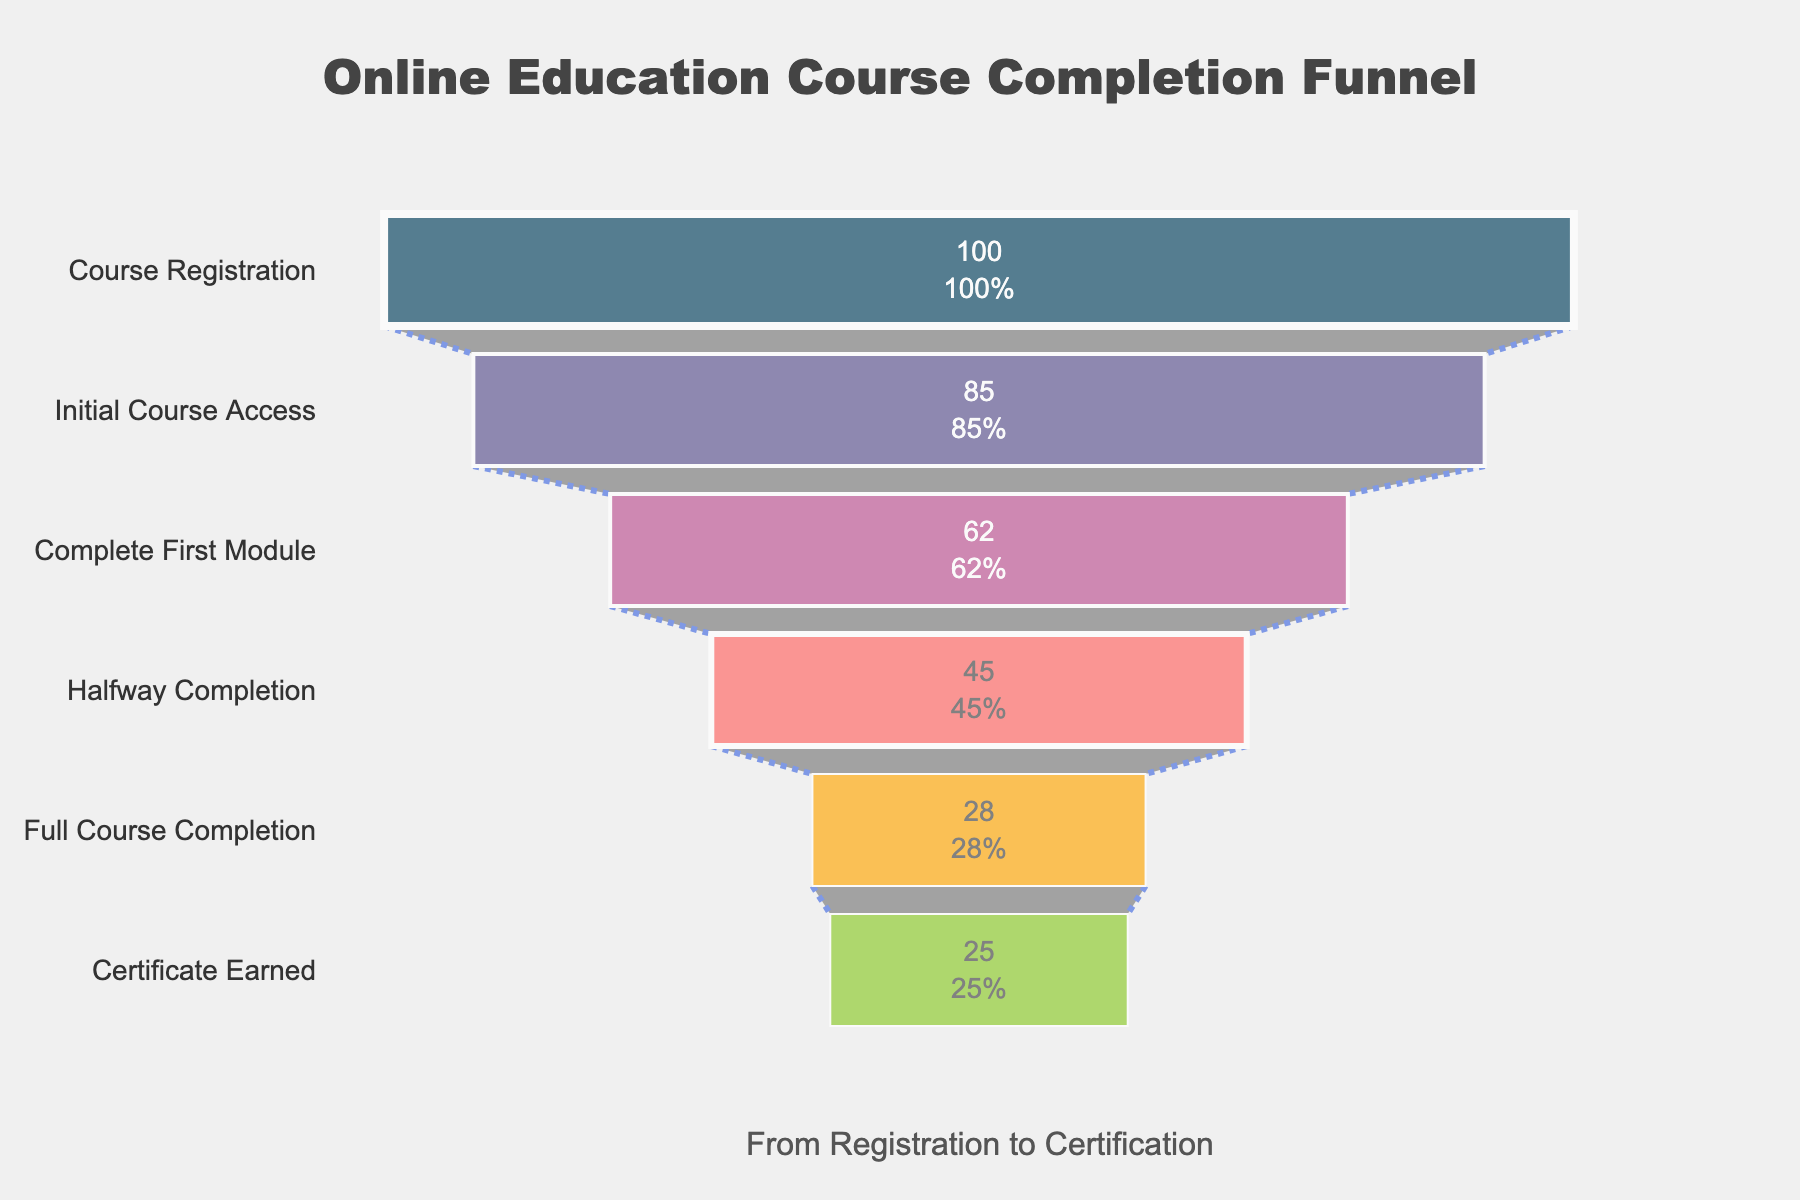What is the title of the funnel chart? The title is located at the top of the chart, and it is prominently displayed in larger font size. It reads "Online Education Course Completion Funnel".
Answer: Online Education Course Completion Funnel Which stage has the largest drop-off in percentage? To find the stage with the largest drop-off, compare the percentage changes between successive stages. The largest drop-off is from the "Initial Course Access" stage (85%) to the "Complete First Module" stage (62%), which is a drop of 23%.
Answer: Initial Course Access to Complete First Module What percentage of users complete the full course? According to the funnel chart, the percentage of users who reach the "Full Course Completion" stage is displayed. It shows 28%.
Answer: 28% What is the difference in percentage between users who register and users who earn a certificate? To find the difference, subtract the percentage of users who earn a certificate (25%) from those who registered (100%). The calculation is 100% - 25% = 75%.
Answer: 75% Which two stages have the smallest percentage difference between them? Compare the percentage differences between all successive stages. The smallest difference is between "Full Course Completion" (28%) and "Certificate Earned" (25%), which is 3%.
Answer: Full Course Completion and Certificate Earned How many unique stages are shown in the chart? Count the number of distinct stages listed on the y-axis. They are six: Course Registration, Initial Course Access, Complete First Module, Halfway Completion, Full Course Completion, and Certificate Earned.
Answer: 6 What is the percentage of participants who access the course initially after registration? The funnel chart shows the percentage of participants at each stage. After registration, the "Initial Course Access" stage shows 85%.
Answer: 85% By what percentage does the completion rate decrease from "Complete First Module" to "Halfway Completion"? Subtract the percentage of "Halfway Completion" (45%) from "Complete First Module" (62%). The calculation is 62% - 45% = 17%.
Answer: 17% What is the percentage retention rate from "Halfway Completion" to "Full Course Completion"? To find the retention rate, compare the percentages of "Halfway Completion" (45%) and "Full Course Completion" (28%). The calculation shows that 28%/45% = 0.6222, which is approximately 62.22%.
Answer: 62.22% 